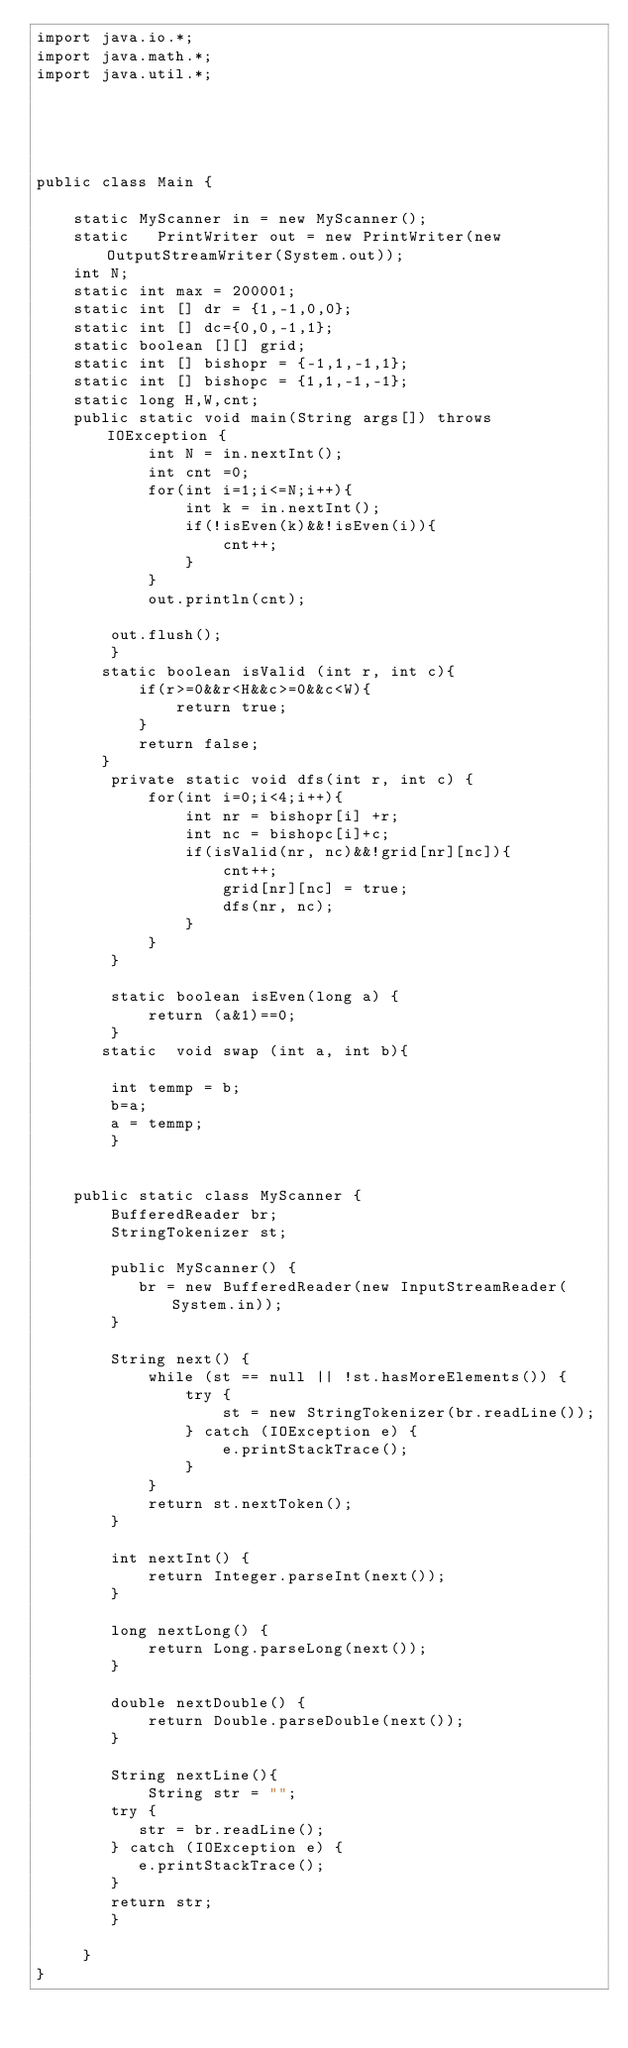Convert code to text. <code><loc_0><loc_0><loc_500><loc_500><_Java_>import java.io.*;
import java.math.*;
import java.util.*;





public class Main {

    static MyScanner in = new MyScanner();
    static   PrintWriter out = new PrintWriter(new OutputStreamWriter(System.out));
    int N;
    static int max = 200001;
    static int [] dr = {1,-1,0,0};
    static int [] dc={0,0,-1,1};
    static boolean [][] grid;
    static int [] bishopr = {-1,1,-1,1};
    static int [] bishopc = {1,1,-1,-1};
    static long H,W,cnt;
    public static void main(String args[]) throws IOException {
            int N = in.nextInt();
            int cnt =0;
            for(int i=1;i<=N;i++){
                int k = in.nextInt();
                if(!isEven(k)&&!isEven(i)){
                    cnt++;
                }
            }
            out.println(cnt);

        out.flush();
        }
       static boolean isValid (int r, int c){
           if(r>=0&&r<H&&c>=0&&c<W){
               return true;
           }
           return false;
       }
        private static void dfs(int r, int c) {
            for(int i=0;i<4;i++){
                int nr = bishopr[i] +r;
                int nc = bishopc[i]+c;
                if(isValid(nr, nc)&&!grid[nr][nc]){
                    cnt++;
                    grid[nr][nc] = true;
                    dfs(nr, nc);
                }
            }
        }

        static boolean isEven(long a) {
            return (a&1)==0;
        }
       static  void swap (int a, int b){

        int temmp = b;
        b=a;
        a = temmp;
        }
    

    public static class MyScanner {
        BufferedReader br;
        StringTokenizer st;
   
        public MyScanner() {
           br = new BufferedReader(new InputStreamReader(System.in));
        }
   
        String next() {
            while (st == null || !st.hasMoreElements()) {
                try {
                    st = new StringTokenizer(br.readLine());
                } catch (IOException e) {
                    e.printStackTrace();
                }
            }
            return st.nextToken();
        }
   
        int nextInt() {
            return Integer.parseInt(next());
        }
   
        long nextLong() {
            return Long.parseLong(next());
        }
   
        double nextDouble() {
            return Double.parseDouble(next());
        }
   
        String nextLine(){
            String str = "";
        try {
           str = br.readLine();
        } catch (IOException e) {
           e.printStackTrace();
        }
        return str;
        }
  
     }
}</code> 